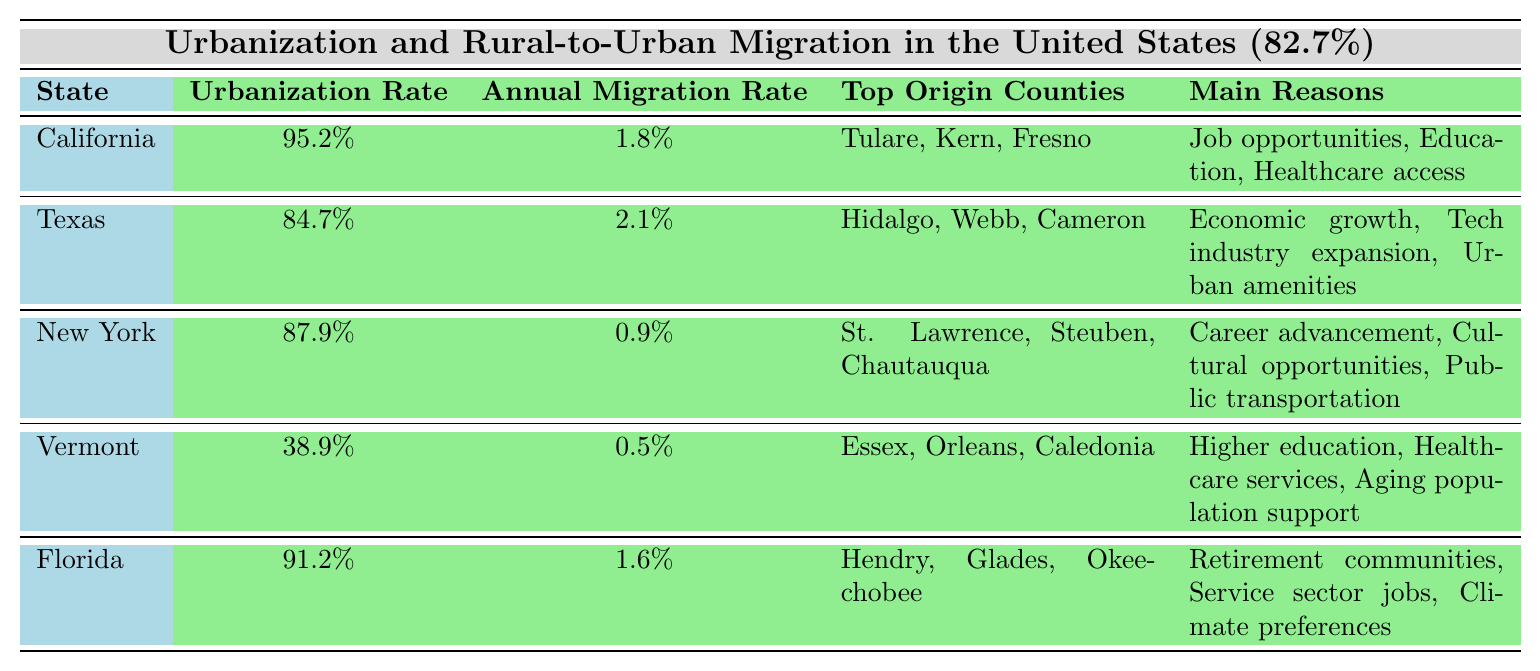What is the urbanization rate of California? The table indicates the urbanization rate of California is specifically listed under the "Urbanization Rate" column for that state.
Answer: 95.2% Which state has the highest urbanization rate? By comparing the "Urbanization Rate" values in the table, California's rate of 95.2% is the highest among all the states listed.
Answer: California What are the main reasons for rural-to-urban migration in Texas? The table provides a list of reasons for rural-to-urban migration under the "Main Reasons" column for Texas, which are: Economic growth, Tech industry expansion, and Urban amenities.
Answer: Economic growth, Tech industry expansion, Urban amenities How does Vermont's annual migration rate compare to California's? The table shows Vermont's annual migration rate is 0.5% while California's is 1.8%. By comparison, California has a higher migration rate than Vermont.
Answer: California has a higher migration rate What is the average urbanization rate of the states listed in the table? The urbanization rates are: California (95.2%), Texas (84.7%), New York (87.9%), Vermont (38.9%), and Florida (91.2%). Summing these gives 95.2 + 84.7 + 87.9 + 38.9 + 91.2 = 397.9. There are 5 states, so the average is 397.9 / 5 = 79.58%.
Answer: 79.58% Is it true that New York has a rural-to-urban migration rate of 1% or higher? The table specifies New York's annual migration rate is 0.9%, which is less than 1%. Hence, the statement is false.
Answer: No Which state has the lowest urbanization rate and what are the reasons for migration in that state? The table shows Vermont has the lowest urbanization rate at 38.9%. Its main reasons for migration listed are higher education, healthcare services, and aging population support.
Answer: Vermont; Higher education, Healthcare services, Aging population support If we combine the migration rates of Texas and Florida, what will be the total? Texas has a migration rate of 2.1% and Florida of 1.6%. Adding these together, we get 2.1 + 1.6 = 3.7%.
Answer: 3.7% Which counties are the top origin counties for rural-to-urban migration in Florida? The table lists the top origin counties for Florida under the "Top Origin Counties" column as Hendry, Glades, and Okeechobee.
Answer: Hendry, Glades, Okeechobee How many states have urbanization rates below 90%? The table indicates that Vermont is the only state with an urbanization rate below 90%, as all other states listed have rates above 90%.
Answer: 1 Are the main reasons for migration in states with urbanization rates above 90% primarily related to economic factors? The main reasons for migration in California and Florida relate primarily to job opportunities and economic aspects like service sector jobs, indicating a trend towards economic factors. Thus, it seems generally accurate for these states.
Answer: Yes 